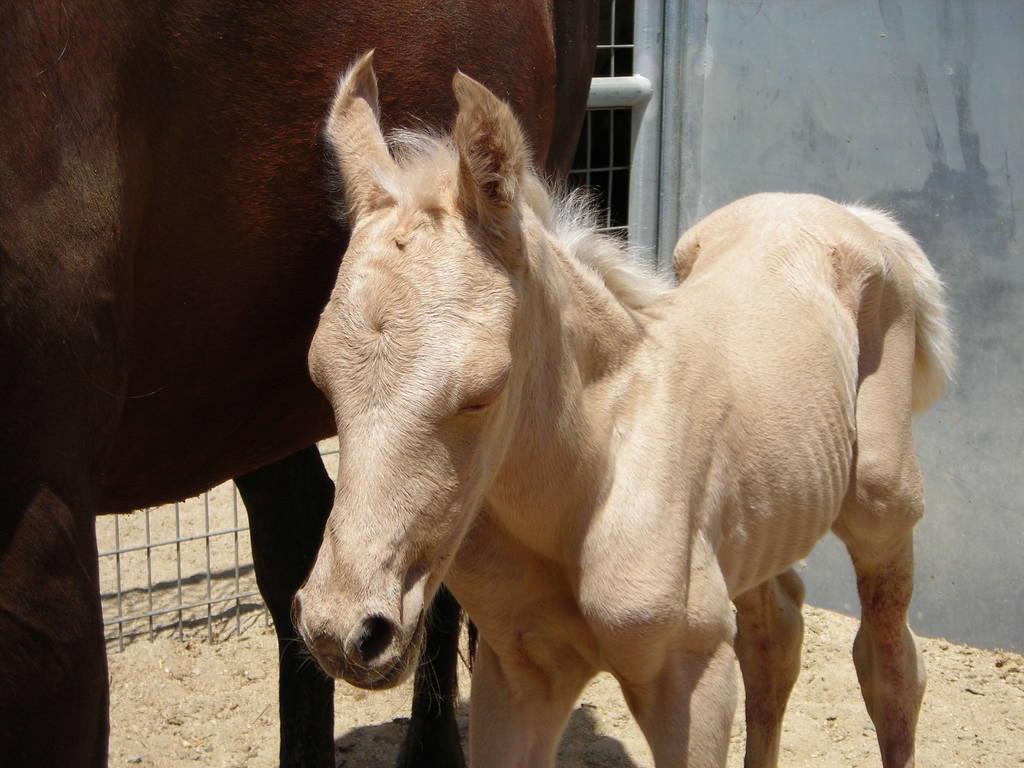Please provide a concise description of this image. In this picture there are horses. At the bottom there is sand. Behind the horses there is a gate. On the right it is well. 